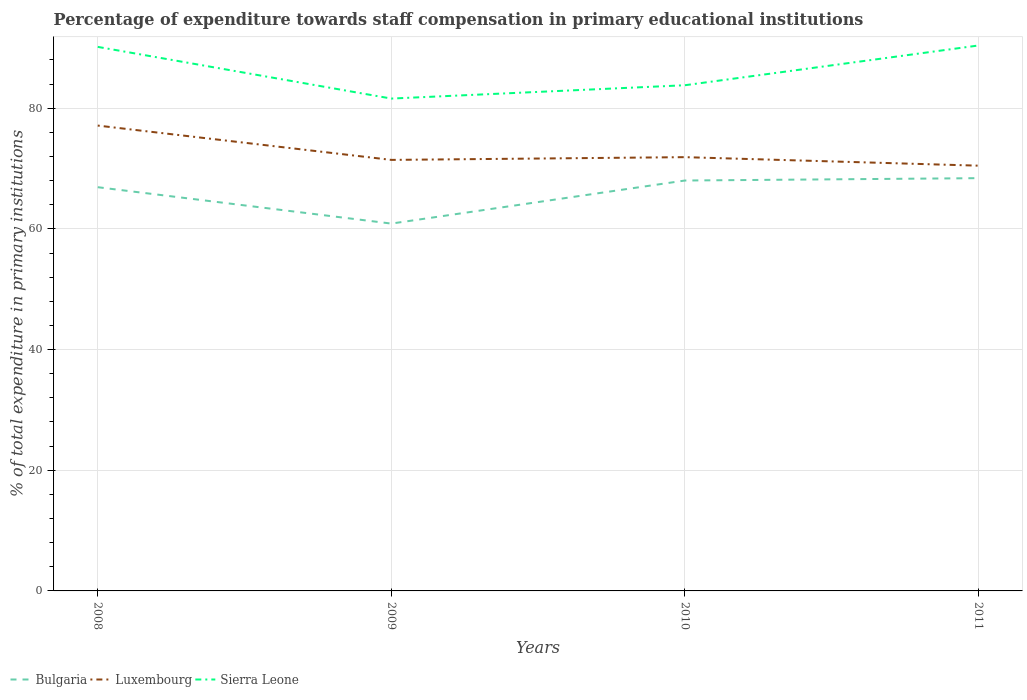How many different coloured lines are there?
Give a very brief answer. 3. Across all years, what is the maximum percentage of expenditure towards staff compensation in Sierra Leone?
Your answer should be very brief. 81.6. What is the total percentage of expenditure towards staff compensation in Sierra Leone in the graph?
Offer a very short reply. 6.36. What is the difference between the highest and the second highest percentage of expenditure towards staff compensation in Sierra Leone?
Provide a succinct answer. 8.8. What is the difference between the highest and the lowest percentage of expenditure towards staff compensation in Luxembourg?
Give a very brief answer. 1. How many lines are there?
Provide a short and direct response. 3. Are the values on the major ticks of Y-axis written in scientific E-notation?
Make the answer very short. No. Where does the legend appear in the graph?
Provide a succinct answer. Bottom left. How many legend labels are there?
Your answer should be compact. 3. What is the title of the graph?
Provide a succinct answer. Percentage of expenditure towards staff compensation in primary educational institutions. Does "Uganda" appear as one of the legend labels in the graph?
Provide a short and direct response. No. What is the label or title of the Y-axis?
Keep it short and to the point. % of total expenditure in primary institutions. What is the % of total expenditure in primary institutions of Bulgaria in 2008?
Ensure brevity in your answer.  66.91. What is the % of total expenditure in primary institutions in Luxembourg in 2008?
Your answer should be compact. 77.13. What is the % of total expenditure in primary institutions in Sierra Leone in 2008?
Offer a terse response. 90.17. What is the % of total expenditure in primary institutions in Bulgaria in 2009?
Your answer should be compact. 60.88. What is the % of total expenditure in primary institutions of Luxembourg in 2009?
Give a very brief answer. 71.44. What is the % of total expenditure in primary institutions of Sierra Leone in 2009?
Keep it short and to the point. 81.6. What is the % of total expenditure in primary institutions of Bulgaria in 2010?
Make the answer very short. 68.02. What is the % of total expenditure in primary institutions of Luxembourg in 2010?
Provide a succinct answer. 71.89. What is the % of total expenditure in primary institutions in Sierra Leone in 2010?
Ensure brevity in your answer.  83.81. What is the % of total expenditure in primary institutions of Bulgaria in 2011?
Offer a terse response. 68.41. What is the % of total expenditure in primary institutions in Luxembourg in 2011?
Give a very brief answer. 70.48. What is the % of total expenditure in primary institutions in Sierra Leone in 2011?
Ensure brevity in your answer.  90.4. Across all years, what is the maximum % of total expenditure in primary institutions of Bulgaria?
Your answer should be compact. 68.41. Across all years, what is the maximum % of total expenditure in primary institutions of Luxembourg?
Ensure brevity in your answer.  77.13. Across all years, what is the maximum % of total expenditure in primary institutions in Sierra Leone?
Ensure brevity in your answer.  90.4. Across all years, what is the minimum % of total expenditure in primary institutions in Bulgaria?
Provide a succinct answer. 60.88. Across all years, what is the minimum % of total expenditure in primary institutions in Luxembourg?
Keep it short and to the point. 70.48. Across all years, what is the minimum % of total expenditure in primary institutions of Sierra Leone?
Offer a very short reply. 81.6. What is the total % of total expenditure in primary institutions in Bulgaria in the graph?
Ensure brevity in your answer.  264.22. What is the total % of total expenditure in primary institutions in Luxembourg in the graph?
Offer a terse response. 290.94. What is the total % of total expenditure in primary institutions in Sierra Leone in the graph?
Offer a terse response. 345.98. What is the difference between the % of total expenditure in primary institutions in Bulgaria in 2008 and that in 2009?
Make the answer very short. 6.03. What is the difference between the % of total expenditure in primary institutions of Luxembourg in 2008 and that in 2009?
Offer a very short reply. 5.69. What is the difference between the % of total expenditure in primary institutions in Sierra Leone in 2008 and that in 2009?
Your response must be concise. 8.57. What is the difference between the % of total expenditure in primary institutions of Bulgaria in 2008 and that in 2010?
Your response must be concise. -1.11. What is the difference between the % of total expenditure in primary institutions in Luxembourg in 2008 and that in 2010?
Make the answer very short. 5.24. What is the difference between the % of total expenditure in primary institutions of Sierra Leone in 2008 and that in 2010?
Offer a very short reply. 6.36. What is the difference between the % of total expenditure in primary institutions in Bulgaria in 2008 and that in 2011?
Make the answer very short. -1.5. What is the difference between the % of total expenditure in primary institutions in Luxembourg in 2008 and that in 2011?
Provide a succinct answer. 6.65. What is the difference between the % of total expenditure in primary institutions in Sierra Leone in 2008 and that in 2011?
Make the answer very short. -0.23. What is the difference between the % of total expenditure in primary institutions in Bulgaria in 2009 and that in 2010?
Offer a terse response. -7.14. What is the difference between the % of total expenditure in primary institutions in Luxembourg in 2009 and that in 2010?
Your answer should be very brief. -0.45. What is the difference between the % of total expenditure in primary institutions in Sierra Leone in 2009 and that in 2010?
Offer a very short reply. -2.21. What is the difference between the % of total expenditure in primary institutions of Bulgaria in 2009 and that in 2011?
Make the answer very short. -7.53. What is the difference between the % of total expenditure in primary institutions in Luxembourg in 2009 and that in 2011?
Offer a terse response. 0.96. What is the difference between the % of total expenditure in primary institutions of Sierra Leone in 2009 and that in 2011?
Provide a short and direct response. -8.8. What is the difference between the % of total expenditure in primary institutions of Bulgaria in 2010 and that in 2011?
Keep it short and to the point. -0.39. What is the difference between the % of total expenditure in primary institutions in Luxembourg in 2010 and that in 2011?
Your answer should be very brief. 1.41. What is the difference between the % of total expenditure in primary institutions in Sierra Leone in 2010 and that in 2011?
Your response must be concise. -6.59. What is the difference between the % of total expenditure in primary institutions of Bulgaria in 2008 and the % of total expenditure in primary institutions of Luxembourg in 2009?
Offer a terse response. -4.53. What is the difference between the % of total expenditure in primary institutions in Bulgaria in 2008 and the % of total expenditure in primary institutions in Sierra Leone in 2009?
Offer a very short reply. -14.69. What is the difference between the % of total expenditure in primary institutions of Luxembourg in 2008 and the % of total expenditure in primary institutions of Sierra Leone in 2009?
Offer a very short reply. -4.48. What is the difference between the % of total expenditure in primary institutions in Bulgaria in 2008 and the % of total expenditure in primary institutions in Luxembourg in 2010?
Offer a very short reply. -4.98. What is the difference between the % of total expenditure in primary institutions in Bulgaria in 2008 and the % of total expenditure in primary institutions in Sierra Leone in 2010?
Provide a succinct answer. -16.9. What is the difference between the % of total expenditure in primary institutions of Luxembourg in 2008 and the % of total expenditure in primary institutions of Sierra Leone in 2010?
Your answer should be very brief. -6.68. What is the difference between the % of total expenditure in primary institutions in Bulgaria in 2008 and the % of total expenditure in primary institutions in Luxembourg in 2011?
Your response must be concise. -3.57. What is the difference between the % of total expenditure in primary institutions in Bulgaria in 2008 and the % of total expenditure in primary institutions in Sierra Leone in 2011?
Make the answer very short. -23.49. What is the difference between the % of total expenditure in primary institutions in Luxembourg in 2008 and the % of total expenditure in primary institutions in Sierra Leone in 2011?
Your answer should be compact. -13.27. What is the difference between the % of total expenditure in primary institutions of Bulgaria in 2009 and the % of total expenditure in primary institutions of Luxembourg in 2010?
Provide a succinct answer. -11.01. What is the difference between the % of total expenditure in primary institutions in Bulgaria in 2009 and the % of total expenditure in primary institutions in Sierra Leone in 2010?
Make the answer very short. -22.93. What is the difference between the % of total expenditure in primary institutions of Luxembourg in 2009 and the % of total expenditure in primary institutions of Sierra Leone in 2010?
Your answer should be very brief. -12.37. What is the difference between the % of total expenditure in primary institutions in Bulgaria in 2009 and the % of total expenditure in primary institutions in Luxembourg in 2011?
Offer a terse response. -9.6. What is the difference between the % of total expenditure in primary institutions of Bulgaria in 2009 and the % of total expenditure in primary institutions of Sierra Leone in 2011?
Keep it short and to the point. -29.52. What is the difference between the % of total expenditure in primary institutions in Luxembourg in 2009 and the % of total expenditure in primary institutions in Sierra Leone in 2011?
Ensure brevity in your answer.  -18.96. What is the difference between the % of total expenditure in primary institutions in Bulgaria in 2010 and the % of total expenditure in primary institutions in Luxembourg in 2011?
Provide a short and direct response. -2.46. What is the difference between the % of total expenditure in primary institutions in Bulgaria in 2010 and the % of total expenditure in primary institutions in Sierra Leone in 2011?
Your answer should be compact. -22.38. What is the difference between the % of total expenditure in primary institutions of Luxembourg in 2010 and the % of total expenditure in primary institutions of Sierra Leone in 2011?
Your answer should be very brief. -18.51. What is the average % of total expenditure in primary institutions of Bulgaria per year?
Give a very brief answer. 66.06. What is the average % of total expenditure in primary institutions of Luxembourg per year?
Your answer should be very brief. 72.73. What is the average % of total expenditure in primary institutions of Sierra Leone per year?
Offer a terse response. 86.5. In the year 2008, what is the difference between the % of total expenditure in primary institutions in Bulgaria and % of total expenditure in primary institutions in Luxembourg?
Provide a short and direct response. -10.21. In the year 2008, what is the difference between the % of total expenditure in primary institutions of Bulgaria and % of total expenditure in primary institutions of Sierra Leone?
Offer a very short reply. -23.26. In the year 2008, what is the difference between the % of total expenditure in primary institutions in Luxembourg and % of total expenditure in primary institutions in Sierra Leone?
Your response must be concise. -13.04. In the year 2009, what is the difference between the % of total expenditure in primary institutions in Bulgaria and % of total expenditure in primary institutions in Luxembourg?
Make the answer very short. -10.56. In the year 2009, what is the difference between the % of total expenditure in primary institutions in Bulgaria and % of total expenditure in primary institutions in Sierra Leone?
Your answer should be very brief. -20.72. In the year 2009, what is the difference between the % of total expenditure in primary institutions in Luxembourg and % of total expenditure in primary institutions in Sierra Leone?
Ensure brevity in your answer.  -10.17. In the year 2010, what is the difference between the % of total expenditure in primary institutions of Bulgaria and % of total expenditure in primary institutions of Luxembourg?
Offer a terse response. -3.87. In the year 2010, what is the difference between the % of total expenditure in primary institutions in Bulgaria and % of total expenditure in primary institutions in Sierra Leone?
Give a very brief answer. -15.79. In the year 2010, what is the difference between the % of total expenditure in primary institutions of Luxembourg and % of total expenditure in primary institutions of Sierra Leone?
Give a very brief answer. -11.92. In the year 2011, what is the difference between the % of total expenditure in primary institutions in Bulgaria and % of total expenditure in primary institutions in Luxembourg?
Provide a succinct answer. -2.07. In the year 2011, what is the difference between the % of total expenditure in primary institutions of Bulgaria and % of total expenditure in primary institutions of Sierra Leone?
Offer a very short reply. -21.99. In the year 2011, what is the difference between the % of total expenditure in primary institutions in Luxembourg and % of total expenditure in primary institutions in Sierra Leone?
Keep it short and to the point. -19.92. What is the ratio of the % of total expenditure in primary institutions of Bulgaria in 2008 to that in 2009?
Offer a terse response. 1.1. What is the ratio of the % of total expenditure in primary institutions of Luxembourg in 2008 to that in 2009?
Offer a very short reply. 1.08. What is the ratio of the % of total expenditure in primary institutions of Sierra Leone in 2008 to that in 2009?
Offer a terse response. 1.1. What is the ratio of the % of total expenditure in primary institutions in Bulgaria in 2008 to that in 2010?
Your response must be concise. 0.98. What is the ratio of the % of total expenditure in primary institutions of Luxembourg in 2008 to that in 2010?
Your answer should be compact. 1.07. What is the ratio of the % of total expenditure in primary institutions of Sierra Leone in 2008 to that in 2010?
Provide a short and direct response. 1.08. What is the ratio of the % of total expenditure in primary institutions of Bulgaria in 2008 to that in 2011?
Keep it short and to the point. 0.98. What is the ratio of the % of total expenditure in primary institutions in Luxembourg in 2008 to that in 2011?
Your response must be concise. 1.09. What is the ratio of the % of total expenditure in primary institutions of Bulgaria in 2009 to that in 2010?
Provide a short and direct response. 0.9. What is the ratio of the % of total expenditure in primary institutions of Luxembourg in 2009 to that in 2010?
Offer a terse response. 0.99. What is the ratio of the % of total expenditure in primary institutions in Sierra Leone in 2009 to that in 2010?
Keep it short and to the point. 0.97. What is the ratio of the % of total expenditure in primary institutions in Bulgaria in 2009 to that in 2011?
Provide a succinct answer. 0.89. What is the ratio of the % of total expenditure in primary institutions of Luxembourg in 2009 to that in 2011?
Give a very brief answer. 1.01. What is the ratio of the % of total expenditure in primary institutions in Sierra Leone in 2009 to that in 2011?
Offer a terse response. 0.9. What is the ratio of the % of total expenditure in primary institutions of Bulgaria in 2010 to that in 2011?
Provide a short and direct response. 0.99. What is the ratio of the % of total expenditure in primary institutions in Luxembourg in 2010 to that in 2011?
Keep it short and to the point. 1.02. What is the ratio of the % of total expenditure in primary institutions of Sierra Leone in 2010 to that in 2011?
Your answer should be very brief. 0.93. What is the difference between the highest and the second highest % of total expenditure in primary institutions of Bulgaria?
Provide a short and direct response. 0.39. What is the difference between the highest and the second highest % of total expenditure in primary institutions of Luxembourg?
Make the answer very short. 5.24. What is the difference between the highest and the second highest % of total expenditure in primary institutions in Sierra Leone?
Make the answer very short. 0.23. What is the difference between the highest and the lowest % of total expenditure in primary institutions of Bulgaria?
Your answer should be very brief. 7.53. What is the difference between the highest and the lowest % of total expenditure in primary institutions of Luxembourg?
Make the answer very short. 6.65. What is the difference between the highest and the lowest % of total expenditure in primary institutions in Sierra Leone?
Your answer should be very brief. 8.8. 